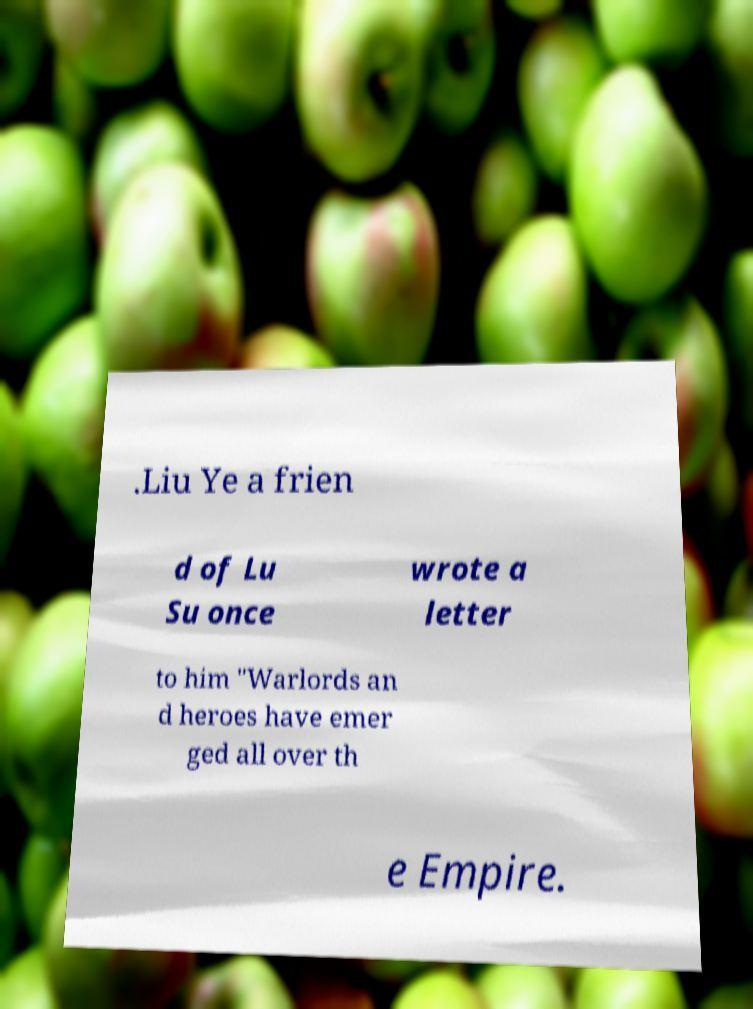Could you extract and type out the text from this image? .Liu Ye a frien d of Lu Su once wrote a letter to him "Warlords an d heroes have emer ged all over th e Empire. 